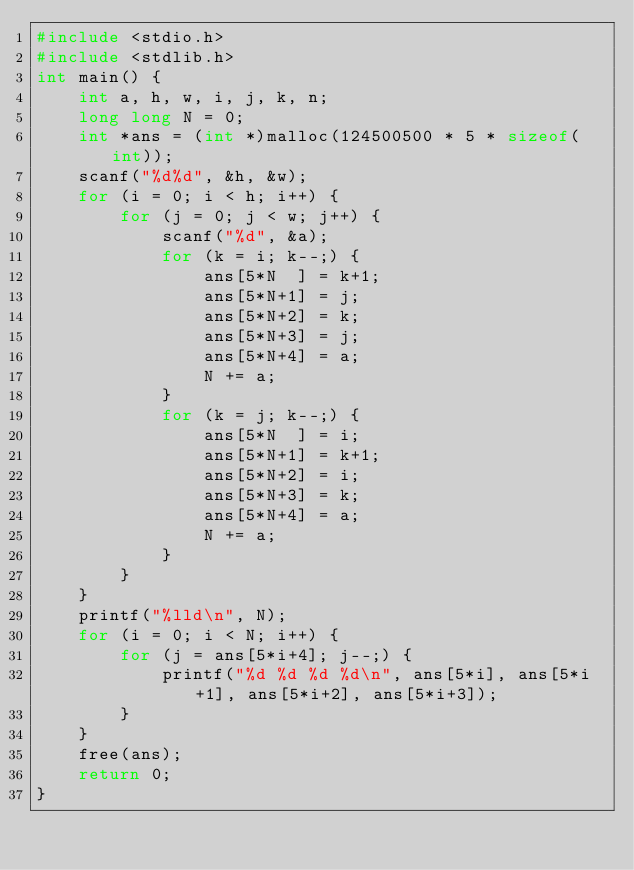Convert code to text. <code><loc_0><loc_0><loc_500><loc_500><_C_>#include <stdio.h>
#include <stdlib.h>
int main() {
    int a, h, w, i, j, k, n;
    long long N = 0;
    int *ans = (int *)malloc(124500500 * 5 * sizeof(int));
    scanf("%d%d", &h, &w);
    for (i = 0; i < h; i++) {
        for (j = 0; j < w; j++) {
            scanf("%d", &a);
            for (k = i; k--;) {
                ans[5*N  ] = k+1;
                ans[5*N+1] = j;
                ans[5*N+2] = k;
                ans[5*N+3] = j;
                ans[5*N+4] = a;
                N += a;
            }
            for (k = j; k--;) {
                ans[5*N  ] = i;
                ans[5*N+1] = k+1;
                ans[5*N+2] = i;
                ans[5*N+3] = k;
                ans[5*N+4] = a;
                N += a;
            }
        }
    }
    printf("%lld\n", N);
    for (i = 0; i < N; i++) {
        for (j = ans[5*i+4]; j--;) {
            printf("%d %d %d %d\n", ans[5*i], ans[5*i+1], ans[5*i+2], ans[5*i+3]);
        }
    }
    free(ans);
    return 0;
}</code> 